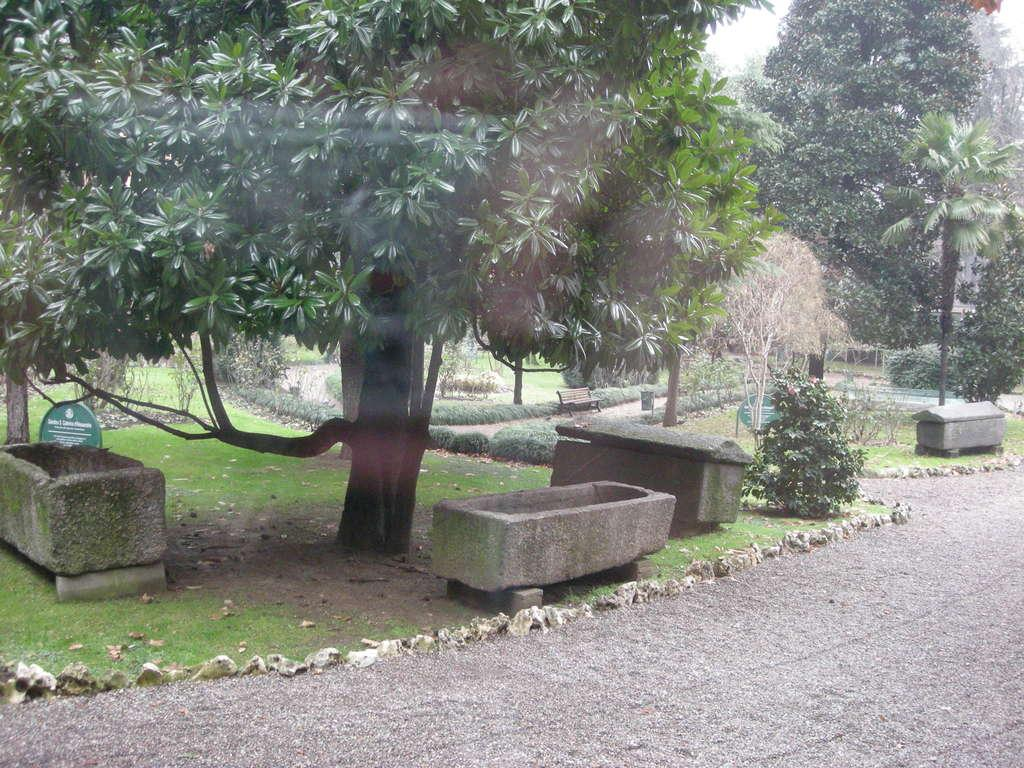What type of location is depicted in the image? There is a park in the image. What can be found within the park? There is a path, trees, cement boxes, and plants in the park. What is visible in the background of the image? The sky is visible in the background of the image. What type of cannon is being used by the writer in the park? There is no cannon or writer present in the image. How many forks are visible in the park? There are no forks visible in the image. 